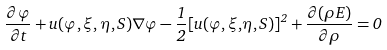<formula> <loc_0><loc_0><loc_500><loc_500>\frac { \partial \varphi } { \partial t } + u ( \varphi , \xi , \eta , S ) \nabla \varphi - { \frac { 1 } { 2 } } { [ u ( } \varphi { , \xi , } \eta , S { ) ] } ^ { 2 } + \frac { \partial ( \rho E ) } { \partial \rho } = 0</formula> 